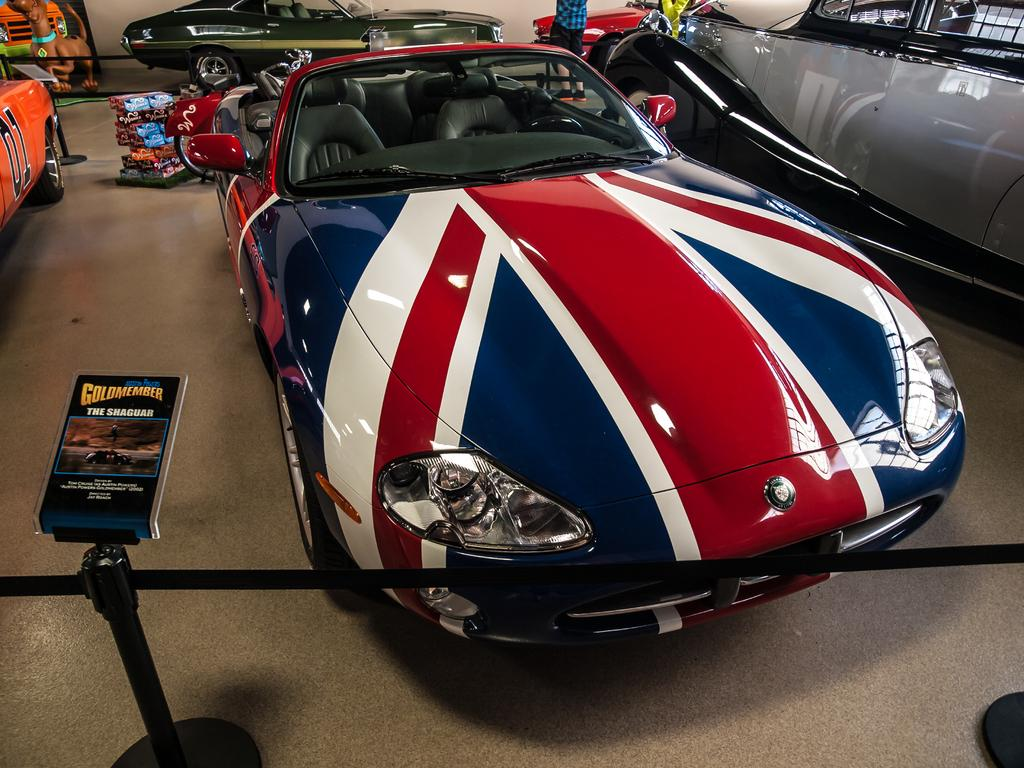What types of objects can be seen in the image? There are vehicles, people, boards, stands, and other objects in the image. Can you describe the vehicles in the image? The vehicles in the image are not specified, but they are present. What is depicted on one of the boards in the image? There is an image of a dog on one of the boards in the image. What are the boards and stands used for in the image? The boards and stands are likely used for displaying or selling items, but their specific purpose is not mentioned. What type of quiver can be seen in the image? There is no quiver present in the image. What flavor of pie is being sold at the stands in the image? There is no mention of pies or flavors in the image. 